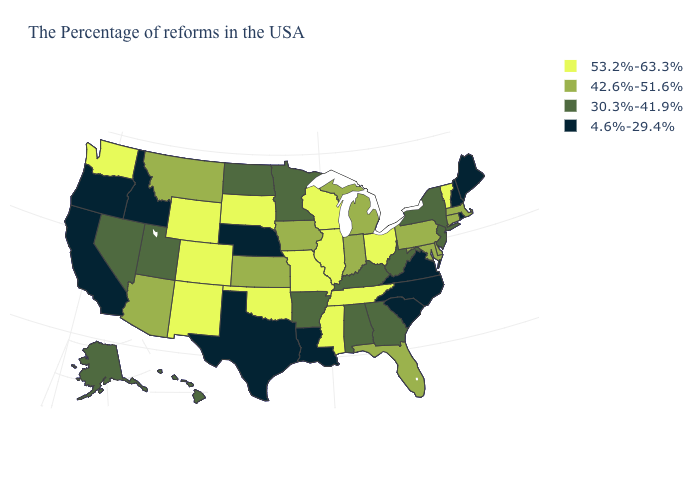What is the highest value in the USA?
Give a very brief answer. 53.2%-63.3%. What is the value of Idaho?
Quick response, please. 4.6%-29.4%. What is the value of South Carolina?
Keep it brief. 4.6%-29.4%. What is the highest value in the MidWest ?
Keep it brief. 53.2%-63.3%. Name the states that have a value in the range 4.6%-29.4%?
Short answer required. Maine, Rhode Island, New Hampshire, Virginia, North Carolina, South Carolina, Louisiana, Nebraska, Texas, Idaho, California, Oregon. What is the value of Wisconsin?
Quick response, please. 53.2%-63.3%. What is the lowest value in the USA?
Answer briefly. 4.6%-29.4%. Name the states that have a value in the range 42.6%-51.6%?
Keep it brief. Massachusetts, Connecticut, Delaware, Maryland, Pennsylvania, Florida, Michigan, Indiana, Iowa, Kansas, Montana, Arizona. Among the states that border West Virginia , which have the highest value?
Keep it brief. Ohio. Which states hav the highest value in the West?
Be succinct. Wyoming, Colorado, New Mexico, Washington. Among the states that border Rhode Island , which have the lowest value?
Be succinct. Massachusetts, Connecticut. Does Alaska have the same value as Rhode Island?
Quick response, please. No. How many symbols are there in the legend?
Short answer required. 4. Name the states that have a value in the range 53.2%-63.3%?
Short answer required. Vermont, Ohio, Tennessee, Wisconsin, Illinois, Mississippi, Missouri, Oklahoma, South Dakota, Wyoming, Colorado, New Mexico, Washington. Name the states that have a value in the range 30.3%-41.9%?
Answer briefly. New York, New Jersey, West Virginia, Georgia, Kentucky, Alabama, Arkansas, Minnesota, North Dakota, Utah, Nevada, Alaska, Hawaii. 